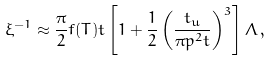<formula> <loc_0><loc_0><loc_500><loc_500>\xi ^ { - 1 } \approx \frac { \pi } { 2 } f ( T ) t \left [ 1 + \frac { 1 } { 2 } \left ( \frac { t _ { u } } { \pi p ^ { 2 } t } \right ) ^ { 3 } \right ] \Lambda \, ,</formula> 